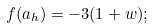<formula> <loc_0><loc_0><loc_500><loc_500>f ( a _ { h } ) = - 3 ( 1 + w ) ;</formula> 